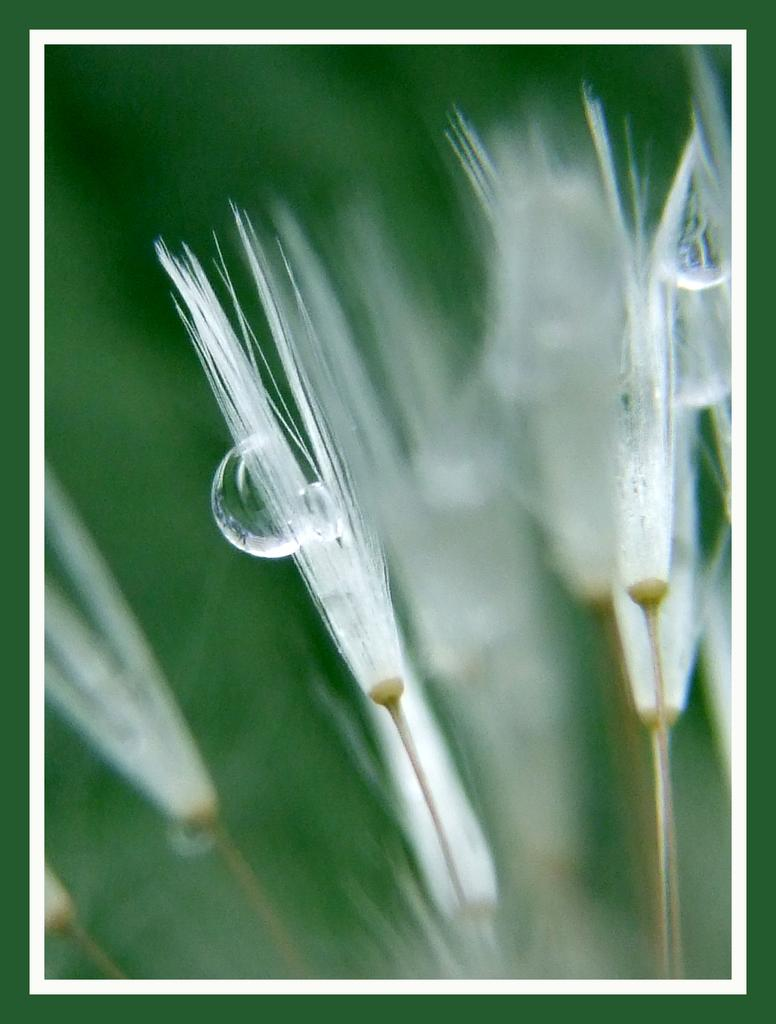What colors are used for the border in the image? The image has a green and white border. What type of flowers can be seen in the image? There are white flowers in the image. What is the unique feature of one of the flowers in the image? There is a water bubble on a flower in the image. How would you describe the background of the image? The background of the image is blurry. Can you tell me how many people are laughing in the image? There are no people present in the image, so it is not possible to determine how many are laughing. 